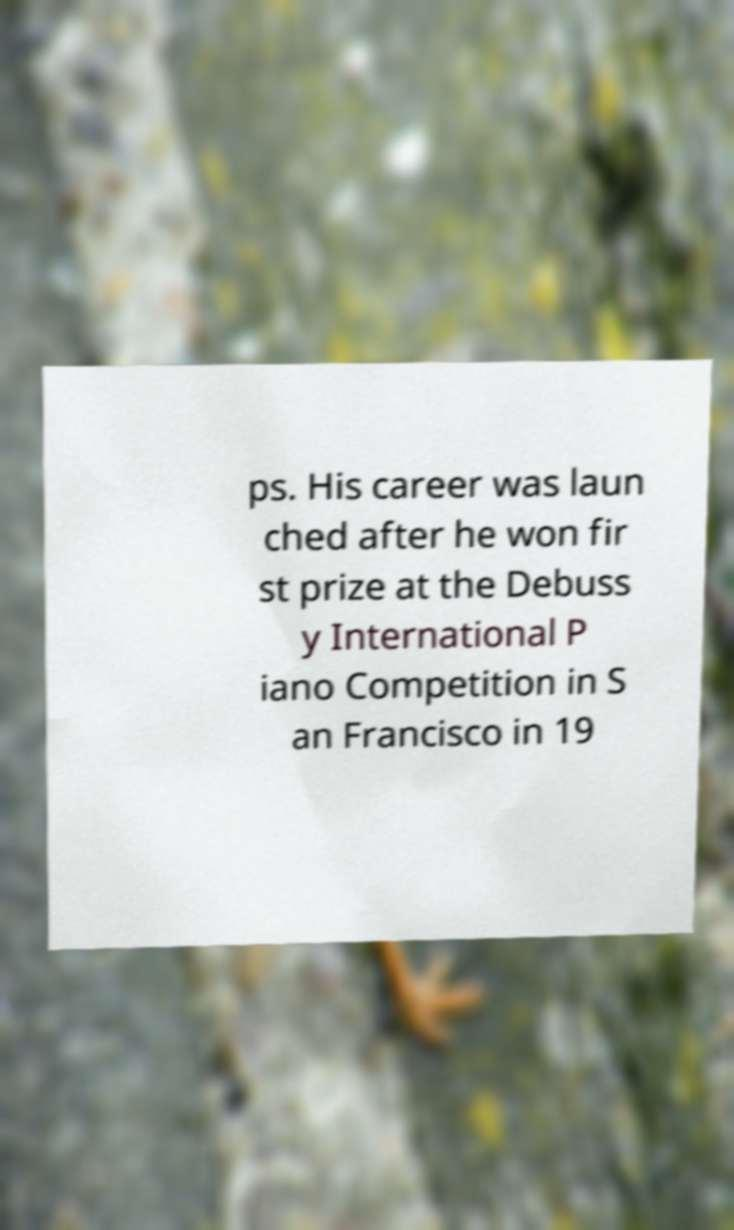Please read and relay the text visible in this image. What does it say? ps. His career was laun ched after he won fir st prize at the Debuss y International P iano Competition in S an Francisco in 19 